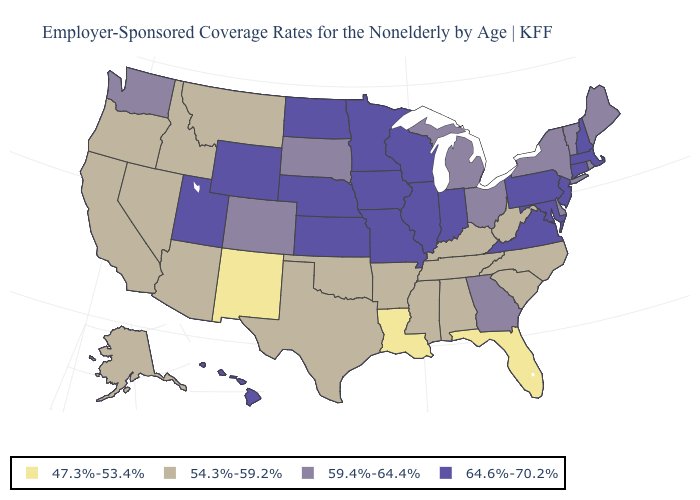Name the states that have a value in the range 47.3%-53.4%?
Quick response, please. Florida, Louisiana, New Mexico. What is the value of Arizona?
Be succinct. 54.3%-59.2%. Does the map have missing data?
Concise answer only. No. What is the lowest value in the MidWest?
Quick response, please. 59.4%-64.4%. Does the first symbol in the legend represent the smallest category?
Write a very short answer. Yes. Among the states that border Arkansas , which have the lowest value?
Give a very brief answer. Louisiana. Name the states that have a value in the range 47.3%-53.4%?
Concise answer only. Florida, Louisiana, New Mexico. Does Pennsylvania have a higher value than Alabama?
Be succinct. Yes. Name the states that have a value in the range 54.3%-59.2%?
Short answer required. Alabama, Alaska, Arizona, Arkansas, California, Idaho, Kentucky, Mississippi, Montana, Nevada, North Carolina, Oklahoma, Oregon, South Carolina, Tennessee, Texas, West Virginia. Among the states that border Maryland , does West Virginia have the lowest value?
Give a very brief answer. Yes. Does the first symbol in the legend represent the smallest category?
Concise answer only. Yes. Does Kentucky have the highest value in the USA?
Short answer required. No. Does Kansas have the lowest value in the MidWest?
Short answer required. No. Does the map have missing data?
Quick response, please. No. Does Montana have the highest value in the West?
Give a very brief answer. No. 